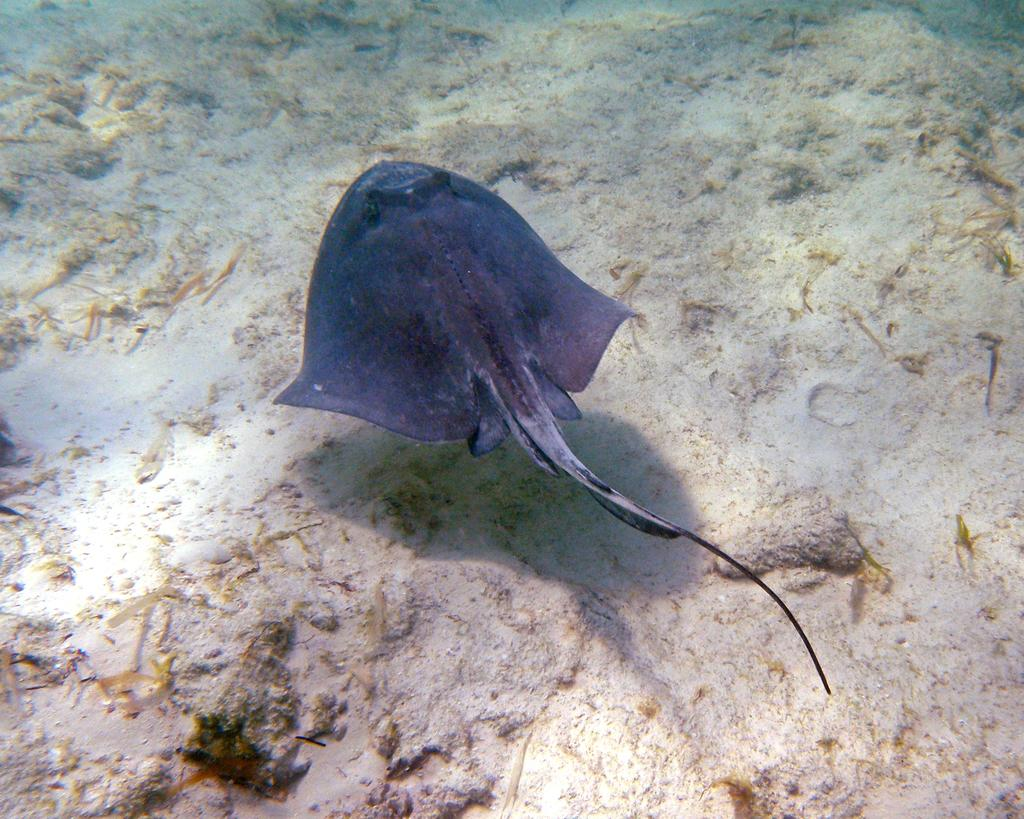What type of animal is in the image? There is a freshwater whipray in the image. Where was the image likely taken? The image appears to be taken underwater. What else can be seen in the image besides the whipray? There are rocks visible in the image. What type of treatment is the whipray receiving in the image? There is no indication in the image that the whipray is receiving any treatment. 